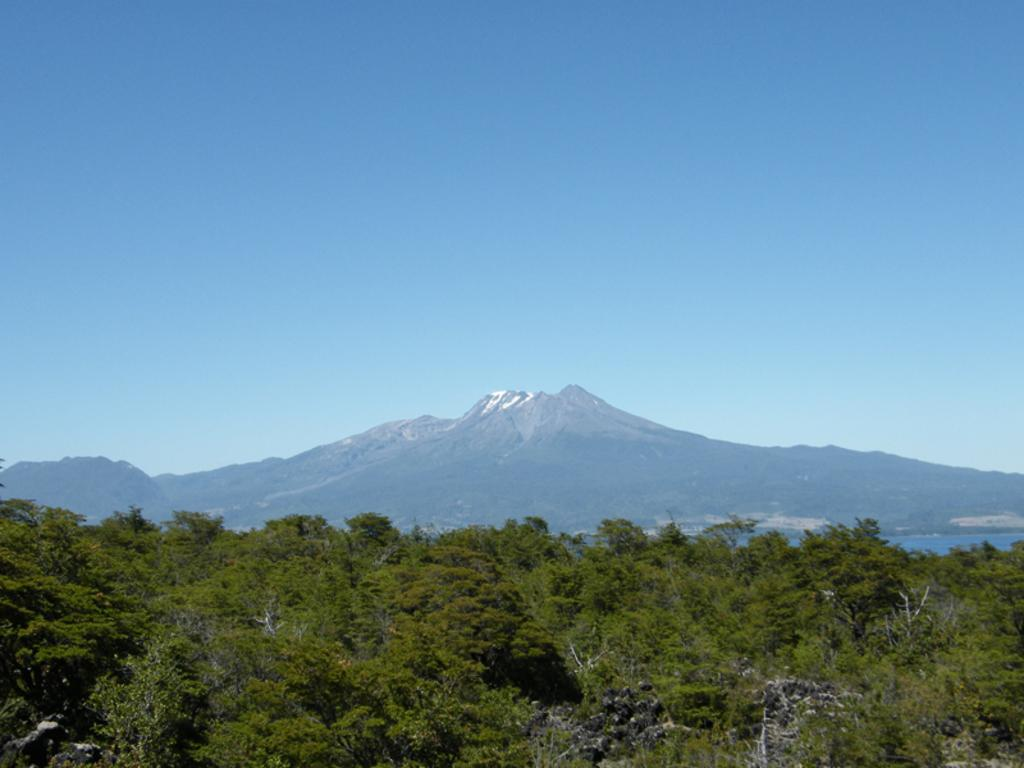What type of natural elements can be seen in the image? There are trees in the image. What type of landscape feature is visible in the background of the image? There are mountains visible in the background of the image. What else can be seen in the background of the image? The sky is visible in the background of the image. What type of shoes can be seen hanging from the trees in the image? There are no shoes present in the image; it only features trees, mountains, and the sky. 